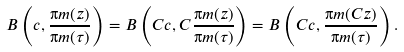Convert formula to latex. <formula><loc_0><loc_0><loc_500><loc_500>B \left ( c , \frac { \i m ( z ) } { \i m ( \tau ) } \right ) = B \left ( C c , C \frac { \i m ( z ) } { \i m ( \tau ) } \right ) = B \left ( C c , \frac { \i m ( C z ) } { \i m ( \tau ) } \right ) .</formula> 